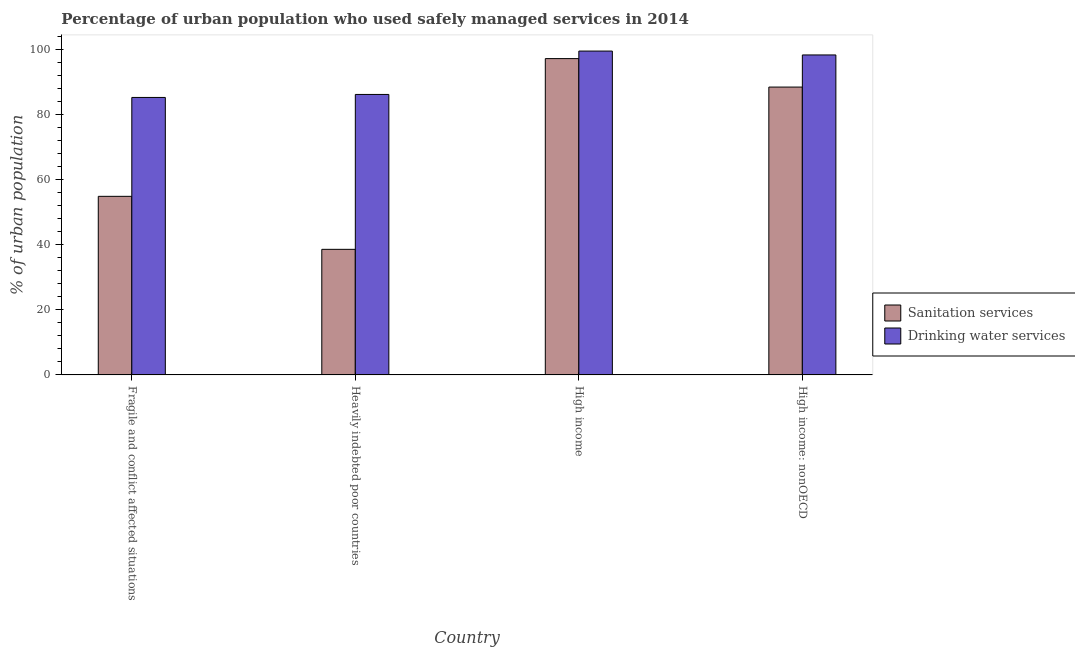How many groups of bars are there?
Offer a terse response. 4. How many bars are there on the 3rd tick from the left?
Offer a very short reply. 2. How many bars are there on the 3rd tick from the right?
Provide a succinct answer. 2. What is the label of the 1st group of bars from the left?
Keep it short and to the point. Fragile and conflict affected situations. What is the percentage of urban population who used sanitation services in High income?
Offer a terse response. 97.14. Across all countries, what is the maximum percentage of urban population who used sanitation services?
Your response must be concise. 97.14. Across all countries, what is the minimum percentage of urban population who used drinking water services?
Provide a short and direct response. 85.21. In which country was the percentage of urban population who used drinking water services minimum?
Offer a very short reply. Fragile and conflict affected situations. What is the total percentage of urban population who used drinking water services in the graph?
Your answer should be very brief. 369.05. What is the difference between the percentage of urban population who used sanitation services in Fragile and conflict affected situations and that in Heavily indebted poor countries?
Provide a short and direct response. 16.27. What is the difference between the percentage of urban population who used sanitation services in High income: nonOECD and the percentage of urban population who used drinking water services in Fragile and conflict affected situations?
Your answer should be very brief. 3.19. What is the average percentage of urban population who used drinking water services per country?
Ensure brevity in your answer.  92.26. What is the difference between the percentage of urban population who used drinking water services and percentage of urban population who used sanitation services in Heavily indebted poor countries?
Make the answer very short. 47.57. In how many countries, is the percentage of urban population who used drinking water services greater than 100 %?
Provide a short and direct response. 0. What is the ratio of the percentage of urban population who used drinking water services in Heavily indebted poor countries to that in High income?
Your answer should be very brief. 0.87. Is the difference between the percentage of urban population who used drinking water services in Fragile and conflict affected situations and High income: nonOECD greater than the difference between the percentage of urban population who used sanitation services in Fragile and conflict affected situations and High income: nonOECD?
Give a very brief answer. Yes. What is the difference between the highest and the second highest percentage of urban population who used drinking water services?
Offer a terse response. 1.19. What is the difference between the highest and the lowest percentage of urban population who used sanitation services?
Keep it short and to the point. 58.57. What does the 2nd bar from the left in Heavily indebted poor countries represents?
Keep it short and to the point. Drinking water services. What does the 2nd bar from the right in High income represents?
Make the answer very short. Sanitation services. Are all the bars in the graph horizontal?
Keep it short and to the point. No. What is the difference between two consecutive major ticks on the Y-axis?
Ensure brevity in your answer.  20. Does the graph contain grids?
Make the answer very short. No. Where does the legend appear in the graph?
Keep it short and to the point. Center right. How many legend labels are there?
Your response must be concise. 2. How are the legend labels stacked?
Offer a terse response. Vertical. What is the title of the graph?
Provide a short and direct response. Percentage of urban population who used safely managed services in 2014. What is the label or title of the X-axis?
Your response must be concise. Country. What is the label or title of the Y-axis?
Give a very brief answer. % of urban population. What is the % of urban population of Sanitation services in Fragile and conflict affected situations?
Ensure brevity in your answer.  54.84. What is the % of urban population of Drinking water services in Fragile and conflict affected situations?
Your answer should be very brief. 85.21. What is the % of urban population in Sanitation services in Heavily indebted poor countries?
Your answer should be very brief. 38.56. What is the % of urban population of Drinking water services in Heavily indebted poor countries?
Offer a terse response. 86.13. What is the % of urban population in Sanitation services in High income?
Your answer should be very brief. 97.14. What is the % of urban population in Drinking water services in High income?
Ensure brevity in your answer.  99.45. What is the % of urban population in Sanitation services in High income: nonOECD?
Offer a very short reply. 88.39. What is the % of urban population in Drinking water services in High income: nonOECD?
Offer a very short reply. 98.26. Across all countries, what is the maximum % of urban population of Sanitation services?
Your answer should be compact. 97.14. Across all countries, what is the maximum % of urban population in Drinking water services?
Offer a terse response. 99.45. Across all countries, what is the minimum % of urban population of Sanitation services?
Offer a very short reply. 38.56. Across all countries, what is the minimum % of urban population in Drinking water services?
Offer a terse response. 85.21. What is the total % of urban population in Sanitation services in the graph?
Your answer should be very brief. 278.93. What is the total % of urban population in Drinking water services in the graph?
Your answer should be very brief. 369.05. What is the difference between the % of urban population of Sanitation services in Fragile and conflict affected situations and that in Heavily indebted poor countries?
Give a very brief answer. 16.27. What is the difference between the % of urban population of Drinking water services in Fragile and conflict affected situations and that in Heavily indebted poor countries?
Your answer should be very brief. -0.92. What is the difference between the % of urban population in Sanitation services in Fragile and conflict affected situations and that in High income?
Offer a terse response. -42.3. What is the difference between the % of urban population of Drinking water services in Fragile and conflict affected situations and that in High income?
Keep it short and to the point. -14.24. What is the difference between the % of urban population of Sanitation services in Fragile and conflict affected situations and that in High income: nonOECD?
Keep it short and to the point. -33.56. What is the difference between the % of urban population of Drinking water services in Fragile and conflict affected situations and that in High income: nonOECD?
Your answer should be compact. -13.05. What is the difference between the % of urban population in Sanitation services in Heavily indebted poor countries and that in High income?
Keep it short and to the point. -58.57. What is the difference between the % of urban population of Drinking water services in Heavily indebted poor countries and that in High income?
Offer a terse response. -13.32. What is the difference between the % of urban population of Sanitation services in Heavily indebted poor countries and that in High income: nonOECD?
Keep it short and to the point. -49.83. What is the difference between the % of urban population of Drinking water services in Heavily indebted poor countries and that in High income: nonOECD?
Provide a short and direct response. -12.13. What is the difference between the % of urban population in Sanitation services in High income and that in High income: nonOECD?
Provide a succinct answer. 8.74. What is the difference between the % of urban population of Drinking water services in High income and that in High income: nonOECD?
Provide a succinct answer. 1.19. What is the difference between the % of urban population of Sanitation services in Fragile and conflict affected situations and the % of urban population of Drinking water services in Heavily indebted poor countries?
Make the answer very short. -31.29. What is the difference between the % of urban population in Sanitation services in Fragile and conflict affected situations and the % of urban population in Drinking water services in High income?
Your response must be concise. -44.61. What is the difference between the % of urban population of Sanitation services in Fragile and conflict affected situations and the % of urban population of Drinking water services in High income: nonOECD?
Provide a succinct answer. -43.42. What is the difference between the % of urban population in Sanitation services in Heavily indebted poor countries and the % of urban population in Drinking water services in High income?
Your answer should be compact. -60.89. What is the difference between the % of urban population of Sanitation services in Heavily indebted poor countries and the % of urban population of Drinking water services in High income: nonOECD?
Ensure brevity in your answer.  -59.69. What is the difference between the % of urban population of Sanitation services in High income and the % of urban population of Drinking water services in High income: nonOECD?
Offer a terse response. -1.12. What is the average % of urban population in Sanitation services per country?
Provide a short and direct response. 69.73. What is the average % of urban population of Drinking water services per country?
Offer a very short reply. 92.26. What is the difference between the % of urban population of Sanitation services and % of urban population of Drinking water services in Fragile and conflict affected situations?
Your answer should be compact. -30.37. What is the difference between the % of urban population of Sanitation services and % of urban population of Drinking water services in Heavily indebted poor countries?
Offer a very short reply. -47.57. What is the difference between the % of urban population of Sanitation services and % of urban population of Drinking water services in High income?
Your answer should be very brief. -2.31. What is the difference between the % of urban population of Sanitation services and % of urban population of Drinking water services in High income: nonOECD?
Offer a very short reply. -9.86. What is the ratio of the % of urban population in Sanitation services in Fragile and conflict affected situations to that in Heavily indebted poor countries?
Provide a succinct answer. 1.42. What is the ratio of the % of urban population in Drinking water services in Fragile and conflict affected situations to that in Heavily indebted poor countries?
Make the answer very short. 0.99. What is the ratio of the % of urban population of Sanitation services in Fragile and conflict affected situations to that in High income?
Your response must be concise. 0.56. What is the ratio of the % of urban population of Drinking water services in Fragile and conflict affected situations to that in High income?
Your answer should be compact. 0.86. What is the ratio of the % of urban population in Sanitation services in Fragile and conflict affected situations to that in High income: nonOECD?
Give a very brief answer. 0.62. What is the ratio of the % of urban population in Drinking water services in Fragile and conflict affected situations to that in High income: nonOECD?
Provide a succinct answer. 0.87. What is the ratio of the % of urban population in Sanitation services in Heavily indebted poor countries to that in High income?
Offer a terse response. 0.4. What is the ratio of the % of urban population of Drinking water services in Heavily indebted poor countries to that in High income?
Offer a terse response. 0.87. What is the ratio of the % of urban population in Sanitation services in Heavily indebted poor countries to that in High income: nonOECD?
Your answer should be very brief. 0.44. What is the ratio of the % of urban population in Drinking water services in Heavily indebted poor countries to that in High income: nonOECD?
Make the answer very short. 0.88. What is the ratio of the % of urban population of Sanitation services in High income to that in High income: nonOECD?
Make the answer very short. 1.1. What is the ratio of the % of urban population in Drinking water services in High income to that in High income: nonOECD?
Offer a very short reply. 1.01. What is the difference between the highest and the second highest % of urban population in Sanitation services?
Keep it short and to the point. 8.74. What is the difference between the highest and the second highest % of urban population of Drinking water services?
Provide a succinct answer. 1.19. What is the difference between the highest and the lowest % of urban population in Sanitation services?
Your response must be concise. 58.57. What is the difference between the highest and the lowest % of urban population of Drinking water services?
Your answer should be compact. 14.24. 